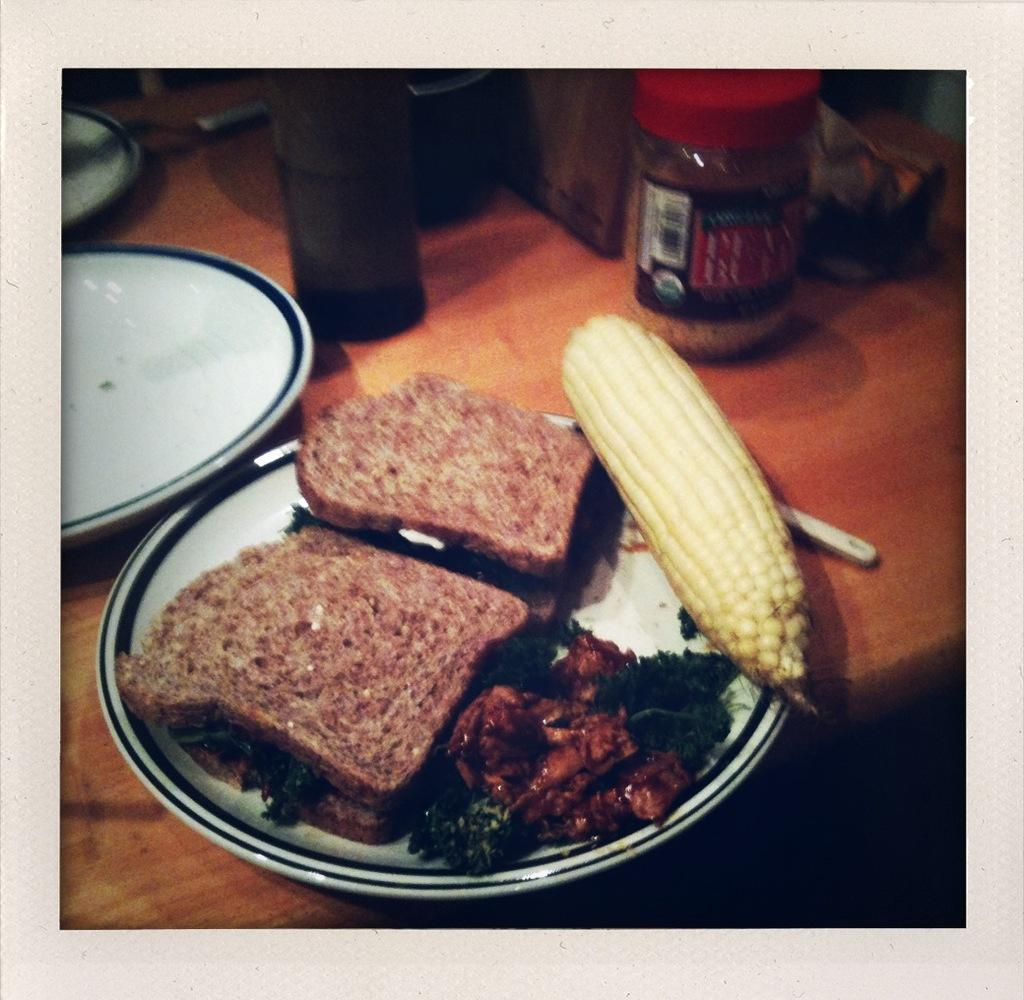What type of food can be seen in the image? There are bread slices in the image. What is the bread slices placed on? The bread slices are on a white color plate. Are there any other food items visible in the image? Yes, there is a corn in the image. What type of stem can be seen growing from the corn in the image? There is no stem visible in the image; only the corn itself is present. 